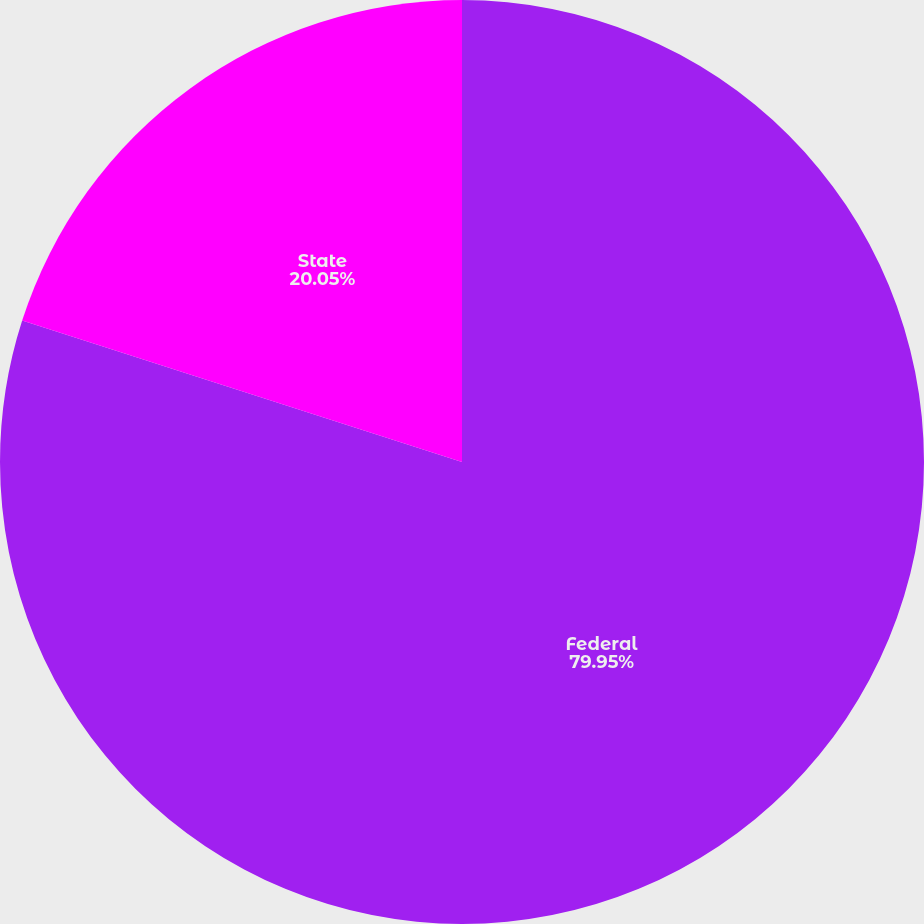Convert chart. <chart><loc_0><loc_0><loc_500><loc_500><pie_chart><fcel>Federal<fcel>State<nl><fcel>79.95%<fcel>20.05%<nl></chart> 